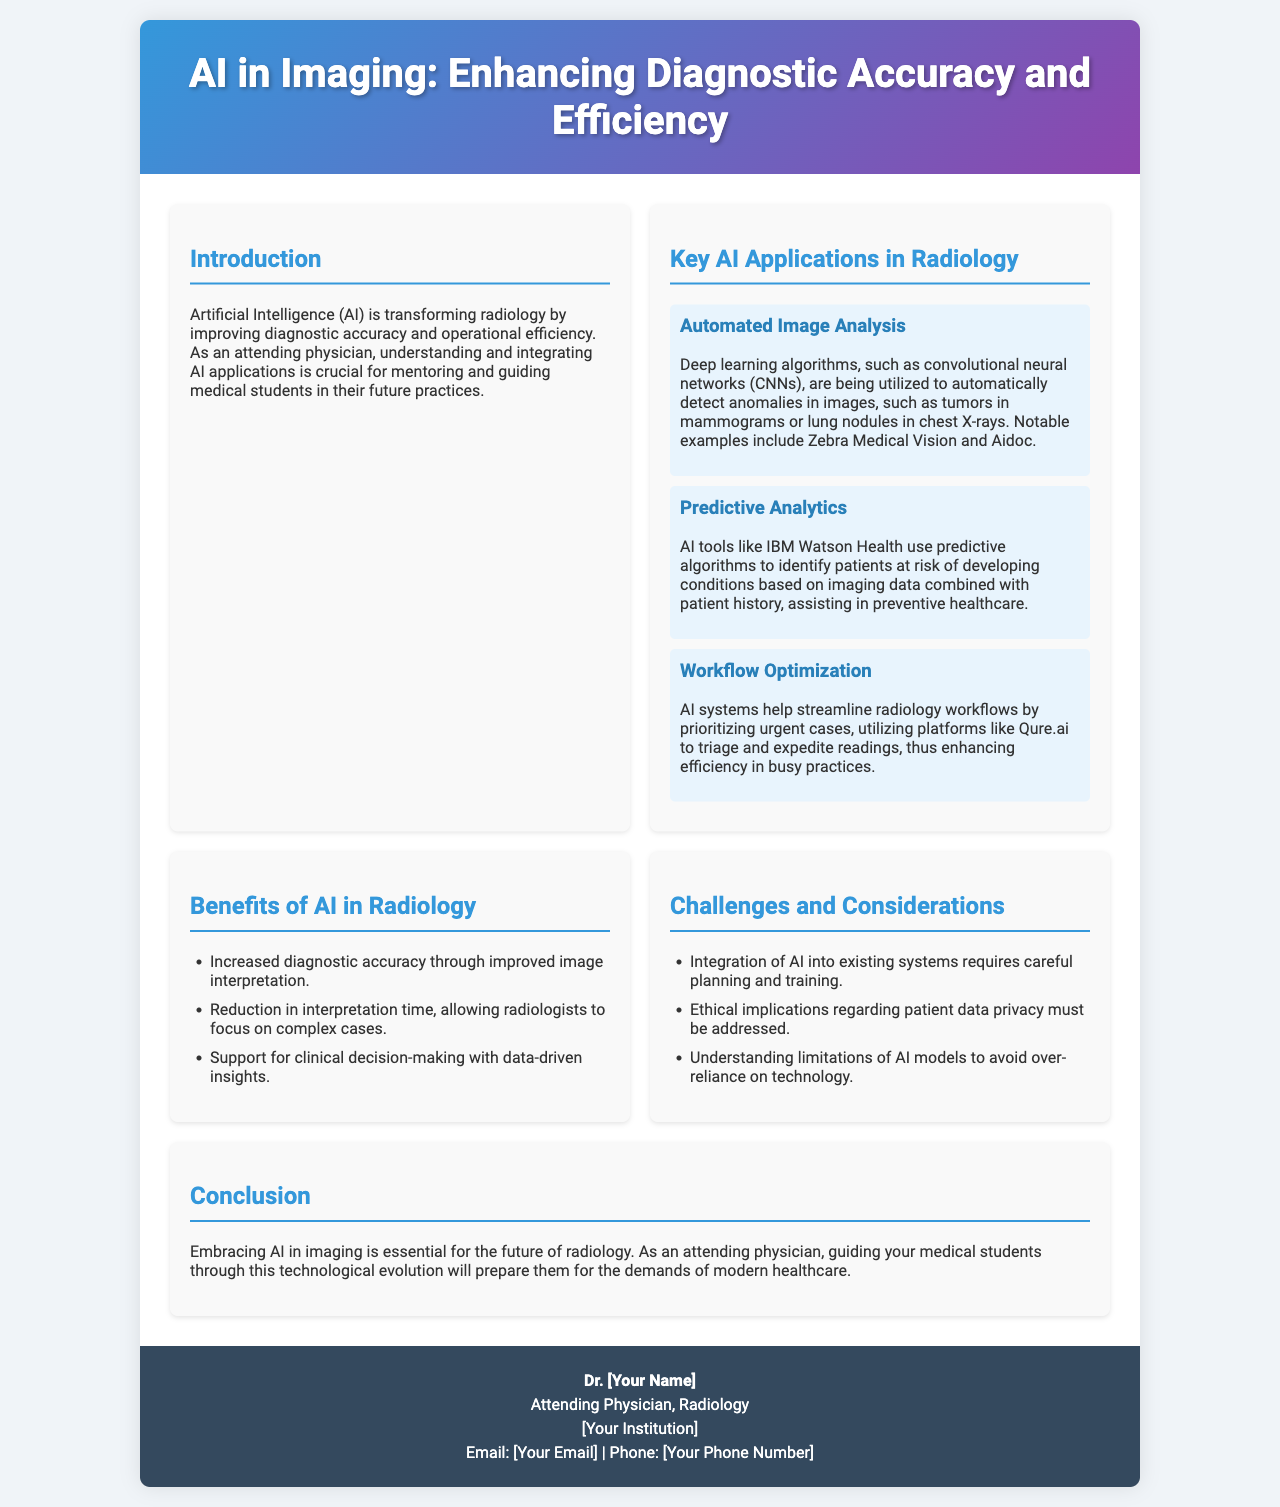What is the main focus of the brochure? The brochure discusses the impact of AI on radiology, emphasizing its role in enhancing diagnostic accuracy and efficiency.
Answer: AI in Imaging Who is the intended audience for this brochure? The brochure is targeted at attending physicians and medical students, highlighting their roles in understanding and integrating AI applications.
Answer: Attending physicians and medical students What technology is specifically mentioned for automated image analysis? The brochure mentions convolutional neural networks (CNNs) as the technology used for automated image analysis.
Answer: Convolutional neural networks (CNNs) What is one example of predictive analytics in AI mentioned? IBM Watson Health is provided as an example of AI tools utilizing predictive analytics to assess patient risk.
Answer: IBM Watson Health What is one challenge associated with integrating AI in radiology? The brochure lists careful planning and training for system integration as a challenge when adopting AI in radiology.
Answer: Integration planning and training What is one key benefit of AI in radiology? The brochure states that one of the benefits includes increased diagnostic accuracy through improved image interpretation.
Answer: Increased diagnostic accuracy What type of AI application is Qure.ai associated with? Qure.ai is referenced in the context of workflow optimization, specifically for prioritizing urgent cases.
Answer: Workflow optimization Which section contains the benefits of AI in radiology? The section titled "Benefits of AI in Radiology" outlines the advantages provided by artificial intelligence in this field.
Answer: Benefits of AI in Radiology How can AI impact the interpretation time for radiologists? The brochure notes that AI can reduce interpretation time, allowing radiologists to concentrate on more complex cases.
Answer: Reduction in interpretation time 